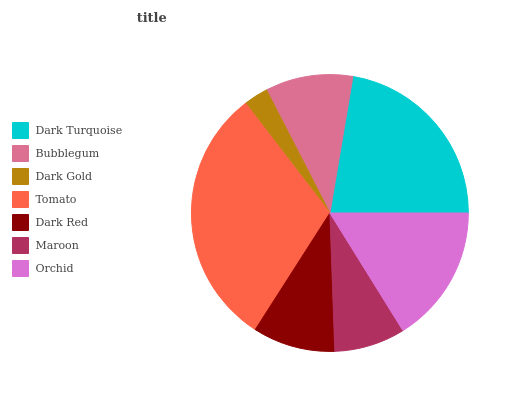Is Dark Gold the minimum?
Answer yes or no. Yes. Is Tomato the maximum?
Answer yes or no. Yes. Is Bubblegum the minimum?
Answer yes or no. No. Is Bubblegum the maximum?
Answer yes or no. No. Is Dark Turquoise greater than Bubblegum?
Answer yes or no. Yes. Is Bubblegum less than Dark Turquoise?
Answer yes or no. Yes. Is Bubblegum greater than Dark Turquoise?
Answer yes or no. No. Is Dark Turquoise less than Bubblegum?
Answer yes or no. No. Is Bubblegum the high median?
Answer yes or no. Yes. Is Bubblegum the low median?
Answer yes or no. Yes. Is Maroon the high median?
Answer yes or no. No. Is Tomato the low median?
Answer yes or no. No. 